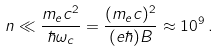<formula> <loc_0><loc_0><loc_500><loc_500>n \ll \frac { m _ { e } c ^ { 2 } } { \hbar { \omega } _ { c } } = \frac { ( m _ { e } c ) ^ { 2 } } { ( e \hbar { ) } B } \approx 1 0 ^ { 9 } \, .</formula> 